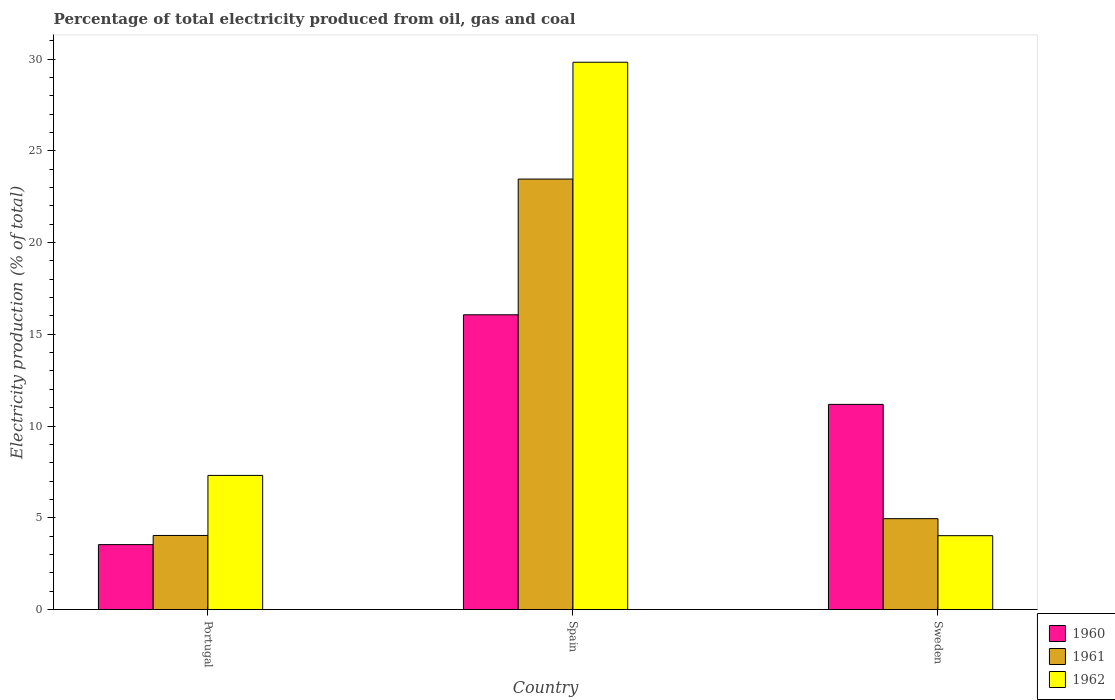Are the number of bars per tick equal to the number of legend labels?
Your response must be concise. Yes. Are the number of bars on each tick of the X-axis equal?
Provide a succinct answer. Yes. What is the electricity production in in 1961 in Sweden?
Make the answer very short. 4.95. Across all countries, what is the maximum electricity production in in 1961?
Your answer should be compact. 23.46. Across all countries, what is the minimum electricity production in in 1960?
Provide a short and direct response. 3.54. In which country was the electricity production in in 1962 maximum?
Make the answer very short. Spain. What is the total electricity production in in 1962 in the graph?
Make the answer very short. 41.16. What is the difference between the electricity production in in 1961 in Portugal and that in Sweden?
Keep it short and to the point. -0.92. What is the difference between the electricity production in in 1962 in Sweden and the electricity production in in 1960 in Spain?
Provide a succinct answer. -12.04. What is the average electricity production in in 1961 per country?
Offer a terse response. 10.82. What is the difference between the electricity production in of/in 1961 and electricity production in of/in 1960 in Sweden?
Provide a succinct answer. -6.23. What is the ratio of the electricity production in in 1962 in Portugal to that in Sweden?
Your response must be concise. 1.82. What is the difference between the highest and the second highest electricity production in in 1961?
Provide a succinct answer. 0.92. What is the difference between the highest and the lowest electricity production in in 1962?
Give a very brief answer. 25.8. In how many countries, is the electricity production in in 1961 greater than the average electricity production in in 1961 taken over all countries?
Provide a succinct answer. 1. What does the 3rd bar from the right in Spain represents?
Make the answer very short. 1960. Is it the case that in every country, the sum of the electricity production in in 1960 and electricity production in in 1962 is greater than the electricity production in in 1961?
Give a very brief answer. Yes. How many bars are there?
Make the answer very short. 9. How many countries are there in the graph?
Give a very brief answer. 3. What is the difference between two consecutive major ticks on the Y-axis?
Offer a terse response. 5. Are the values on the major ticks of Y-axis written in scientific E-notation?
Make the answer very short. No. Does the graph contain any zero values?
Make the answer very short. No. Does the graph contain grids?
Keep it short and to the point. No. How are the legend labels stacked?
Your response must be concise. Vertical. What is the title of the graph?
Keep it short and to the point. Percentage of total electricity produced from oil, gas and coal. Does "1978" appear as one of the legend labels in the graph?
Make the answer very short. No. What is the label or title of the X-axis?
Give a very brief answer. Country. What is the label or title of the Y-axis?
Offer a very short reply. Electricity production (% of total). What is the Electricity production (% of total) in 1960 in Portugal?
Your answer should be very brief. 3.54. What is the Electricity production (% of total) in 1961 in Portugal?
Make the answer very short. 4.04. What is the Electricity production (% of total) in 1962 in Portugal?
Make the answer very short. 7.31. What is the Electricity production (% of total) of 1960 in Spain?
Make the answer very short. 16.06. What is the Electricity production (% of total) of 1961 in Spain?
Provide a short and direct response. 23.46. What is the Electricity production (% of total) in 1962 in Spain?
Offer a very short reply. 29.83. What is the Electricity production (% of total) in 1960 in Sweden?
Give a very brief answer. 11.18. What is the Electricity production (% of total) in 1961 in Sweden?
Provide a succinct answer. 4.95. What is the Electricity production (% of total) of 1962 in Sweden?
Your answer should be very brief. 4.02. Across all countries, what is the maximum Electricity production (% of total) in 1960?
Give a very brief answer. 16.06. Across all countries, what is the maximum Electricity production (% of total) of 1961?
Offer a very short reply. 23.46. Across all countries, what is the maximum Electricity production (% of total) of 1962?
Provide a short and direct response. 29.83. Across all countries, what is the minimum Electricity production (% of total) of 1960?
Keep it short and to the point. 3.54. Across all countries, what is the minimum Electricity production (% of total) of 1961?
Keep it short and to the point. 4.04. Across all countries, what is the minimum Electricity production (% of total) of 1962?
Offer a very short reply. 4.02. What is the total Electricity production (% of total) of 1960 in the graph?
Provide a short and direct response. 30.78. What is the total Electricity production (% of total) in 1961 in the graph?
Make the answer very short. 32.45. What is the total Electricity production (% of total) of 1962 in the graph?
Give a very brief answer. 41.16. What is the difference between the Electricity production (% of total) of 1960 in Portugal and that in Spain?
Your response must be concise. -12.53. What is the difference between the Electricity production (% of total) in 1961 in Portugal and that in Spain?
Your answer should be compact. -19.42. What is the difference between the Electricity production (% of total) of 1962 in Portugal and that in Spain?
Make the answer very short. -22.52. What is the difference between the Electricity production (% of total) of 1960 in Portugal and that in Sweden?
Your answer should be compact. -7.64. What is the difference between the Electricity production (% of total) of 1961 in Portugal and that in Sweden?
Your answer should be compact. -0.92. What is the difference between the Electricity production (% of total) in 1962 in Portugal and that in Sweden?
Offer a very short reply. 3.28. What is the difference between the Electricity production (% of total) in 1960 in Spain and that in Sweden?
Provide a succinct answer. 4.88. What is the difference between the Electricity production (% of total) of 1961 in Spain and that in Sweden?
Your answer should be compact. 18.51. What is the difference between the Electricity production (% of total) in 1962 in Spain and that in Sweden?
Provide a succinct answer. 25.8. What is the difference between the Electricity production (% of total) in 1960 in Portugal and the Electricity production (% of total) in 1961 in Spain?
Your answer should be compact. -19.92. What is the difference between the Electricity production (% of total) in 1960 in Portugal and the Electricity production (% of total) in 1962 in Spain?
Offer a terse response. -26.29. What is the difference between the Electricity production (% of total) of 1961 in Portugal and the Electricity production (% of total) of 1962 in Spain?
Provide a short and direct response. -25.79. What is the difference between the Electricity production (% of total) in 1960 in Portugal and the Electricity production (% of total) in 1961 in Sweden?
Provide a succinct answer. -1.41. What is the difference between the Electricity production (% of total) in 1960 in Portugal and the Electricity production (% of total) in 1962 in Sweden?
Your response must be concise. -0.49. What is the difference between the Electricity production (% of total) of 1961 in Portugal and the Electricity production (% of total) of 1962 in Sweden?
Offer a terse response. 0.01. What is the difference between the Electricity production (% of total) of 1960 in Spain and the Electricity production (% of total) of 1961 in Sweden?
Your answer should be very brief. 11.11. What is the difference between the Electricity production (% of total) in 1960 in Spain and the Electricity production (% of total) in 1962 in Sweden?
Make the answer very short. 12.04. What is the difference between the Electricity production (% of total) of 1961 in Spain and the Electricity production (% of total) of 1962 in Sweden?
Provide a succinct answer. 19.44. What is the average Electricity production (% of total) of 1960 per country?
Give a very brief answer. 10.26. What is the average Electricity production (% of total) of 1961 per country?
Offer a very short reply. 10.82. What is the average Electricity production (% of total) of 1962 per country?
Ensure brevity in your answer.  13.72. What is the difference between the Electricity production (% of total) of 1960 and Electricity production (% of total) of 1961 in Portugal?
Provide a short and direct response. -0.5. What is the difference between the Electricity production (% of total) in 1960 and Electricity production (% of total) in 1962 in Portugal?
Ensure brevity in your answer.  -3.77. What is the difference between the Electricity production (% of total) in 1961 and Electricity production (% of total) in 1962 in Portugal?
Provide a succinct answer. -3.27. What is the difference between the Electricity production (% of total) in 1960 and Electricity production (% of total) in 1961 in Spain?
Provide a succinct answer. -7.4. What is the difference between the Electricity production (% of total) in 1960 and Electricity production (% of total) in 1962 in Spain?
Give a very brief answer. -13.76. What is the difference between the Electricity production (% of total) of 1961 and Electricity production (% of total) of 1962 in Spain?
Keep it short and to the point. -6.37. What is the difference between the Electricity production (% of total) of 1960 and Electricity production (% of total) of 1961 in Sweden?
Offer a terse response. 6.23. What is the difference between the Electricity production (% of total) in 1960 and Electricity production (% of total) in 1962 in Sweden?
Make the answer very short. 7.16. What is the difference between the Electricity production (% of total) of 1961 and Electricity production (% of total) of 1962 in Sweden?
Ensure brevity in your answer.  0.93. What is the ratio of the Electricity production (% of total) of 1960 in Portugal to that in Spain?
Your answer should be compact. 0.22. What is the ratio of the Electricity production (% of total) in 1961 in Portugal to that in Spain?
Give a very brief answer. 0.17. What is the ratio of the Electricity production (% of total) of 1962 in Portugal to that in Spain?
Your answer should be compact. 0.24. What is the ratio of the Electricity production (% of total) in 1960 in Portugal to that in Sweden?
Offer a terse response. 0.32. What is the ratio of the Electricity production (% of total) in 1961 in Portugal to that in Sweden?
Your response must be concise. 0.82. What is the ratio of the Electricity production (% of total) in 1962 in Portugal to that in Sweden?
Your answer should be compact. 1.82. What is the ratio of the Electricity production (% of total) of 1960 in Spain to that in Sweden?
Your answer should be compact. 1.44. What is the ratio of the Electricity production (% of total) of 1961 in Spain to that in Sweden?
Your answer should be very brief. 4.74. What is the ratio of the Electricity production (% of total) of 1962 in Spain to that in Sweden?
Offer a very short reply. 7.41. What is the difference between the highest and the second highest Electricity production (% of total) of 1960?
Make the answer very short. 4.88. What is the difference between the highest and the second highest Electricity production (% of total) in 1961?
Offer a very short reply. 18.51. What is the difference between the highest and the second highest Electricity production (% of total) of 1962?
Your answer should be very brief. 22.52. What is the difference between the highest and the lowest Electricity production (% of total) of 1960?
Provide a short and direct response. 12.53. What is the difference between the highest and the lowest Electricity production (% of total) in 1961?
Make the answer very short. 19.42. What is the difference between the highest and the lowest Electricity production (% of total) of 1962?
Ensure brevity in your answer.  25.8. 